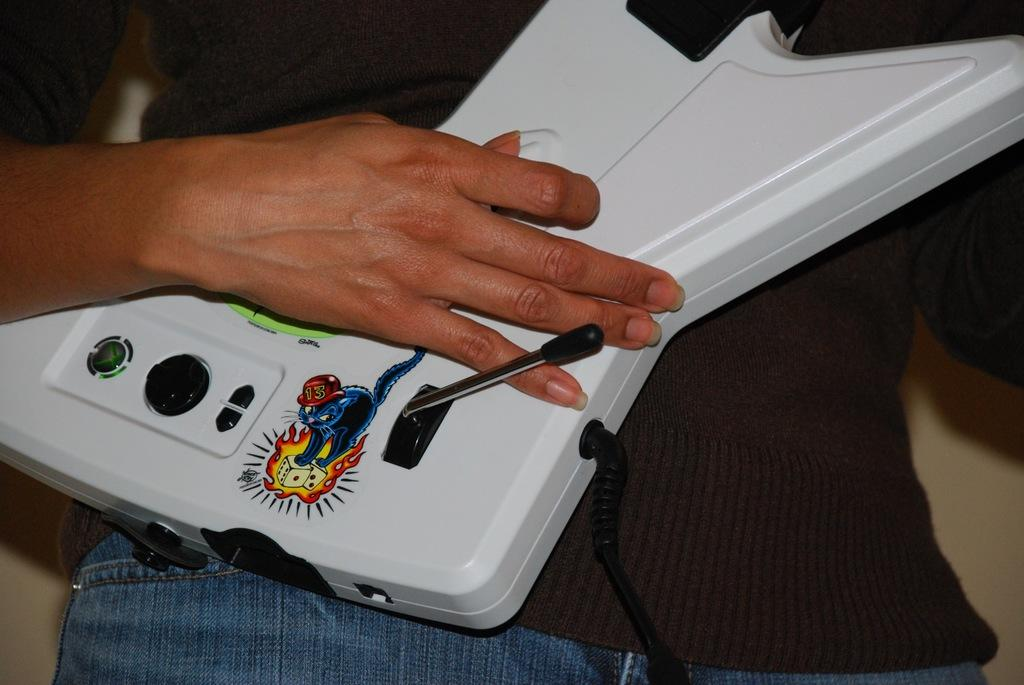Who is present in the image? There is a man in the image. What is the man holding in the image? The man is holding a white object. What is depicted on the white object? The white object has a sticker of a cat. What can be seen on the white object besides the cat sticker? There are visible on the white object. What is visible in the background of the image? There is a wall in the image. Where can the bears be found in the image? There are no bears present in the image. 